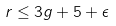Convert formula to latex. <formula><loc_0><loc_0><loc_500><loc_500>r \leq 3 g + 5 + \epsilon</formula> 